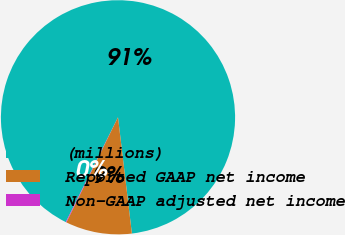Convert chart. <chart><loc_0><loc_0><loc_500><loc_500><pie_chart><fcel>(millions)<fcel>Reported GAAP net income<fcel>Non-GAAP adjusted net income<nl><fcel>90.75%<fcel>9.16%<fcel>0.09%<nl></chart> 